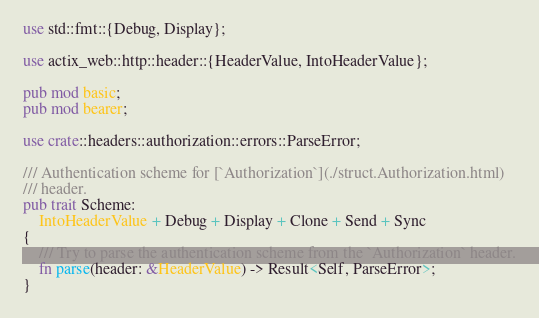<code> <loc_0><loc_0><loc_500><loc_500><_Rust_>use std::fmt::{Debug, Display};

use actix_web::http::header::{HeaderValue, IntoHeaderValue};

pub mod basic;
pub mod bearer;

use crate::headers::authorization::errors::ParseError;

/// Authentication scheme for [`Authorization`](./struct.Authorization.html)
/// header.
pub trait Scheme:
    IntoHeaderValue + Debug + Display + Clone + Send + Sync
{
    /// Try to parse the authentication scheme from the `Authorization` header.
    fn parse(header: &HeaderValue) -> Result<Self, ParseError>;
}
</code> 